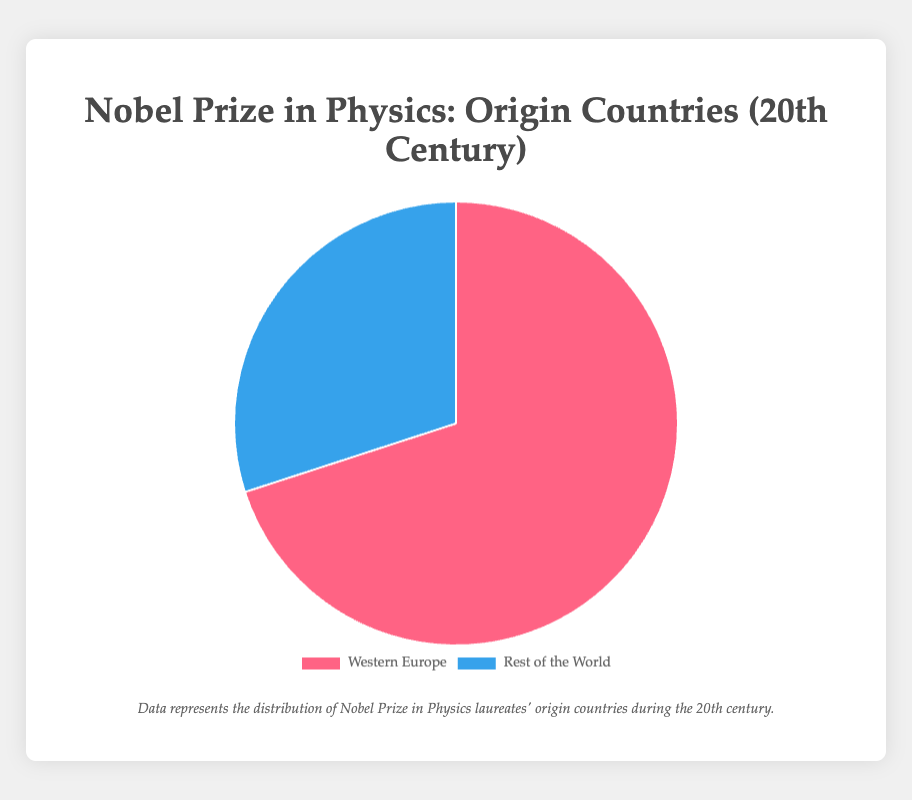Which region has a larger share of Nobel Prize in Physics laureates in the 20th century? The pie chart shows that Western Europe accounts for 70% and the Rest of the World accounts for 30%. Thus, Western Europe has a larger share.
Answer: Western Europe What percentage of Nobel Prize in Physics laureates in the 20th century are from the Rest of the World? The pie chart clearly shows that 30% of the laureates are from the Rest of the World.
Answer: 30% By how much does the percentage of laureates from Western Europe exceed that from the Rest of the World? The pie chart indicates that Western Europe has 70% and the Rest of the World has 30%. Therefore, the percentage exceeds by 70% - 30% = 40%.
Answer: 40% What is the combined percentage of Nobel Prize in Physics laureates from Western Europe and Rest of the World? Since the pie chart includes all regions and their percentages, the combined percentage must be 100%.
Answer: 100% What is the ratio of laureates from Western Europe to those from the Rest of the World? The chart shows that Western Europe represents 70% and the Rest of the World represents 30%. Therefore, the ratio is 70:30, which reduces to 7:3.
Answer: 7:3 If there were 100 Nobel laureates in the 20th century, how many would you expect to be from Western Europe? With Western Europe accounting for 70%, you would expect 0.7 x 100 = 70 laureates from Western Europe.
Answer: 70 If there were 100 Nobel laureates in the 20th century, how many would be from the Rest of the World? With the Rest of the World accounting for 30%, you would expect 0.3 x 100 = 30 laureates from the Rest of the World.
Answer: 30 Which section of the pie chart is represented with a blue color? The pie chart uses blue to represent the Rest of the World, as indicated by its position in the legend.
Answer: Rest of the World 